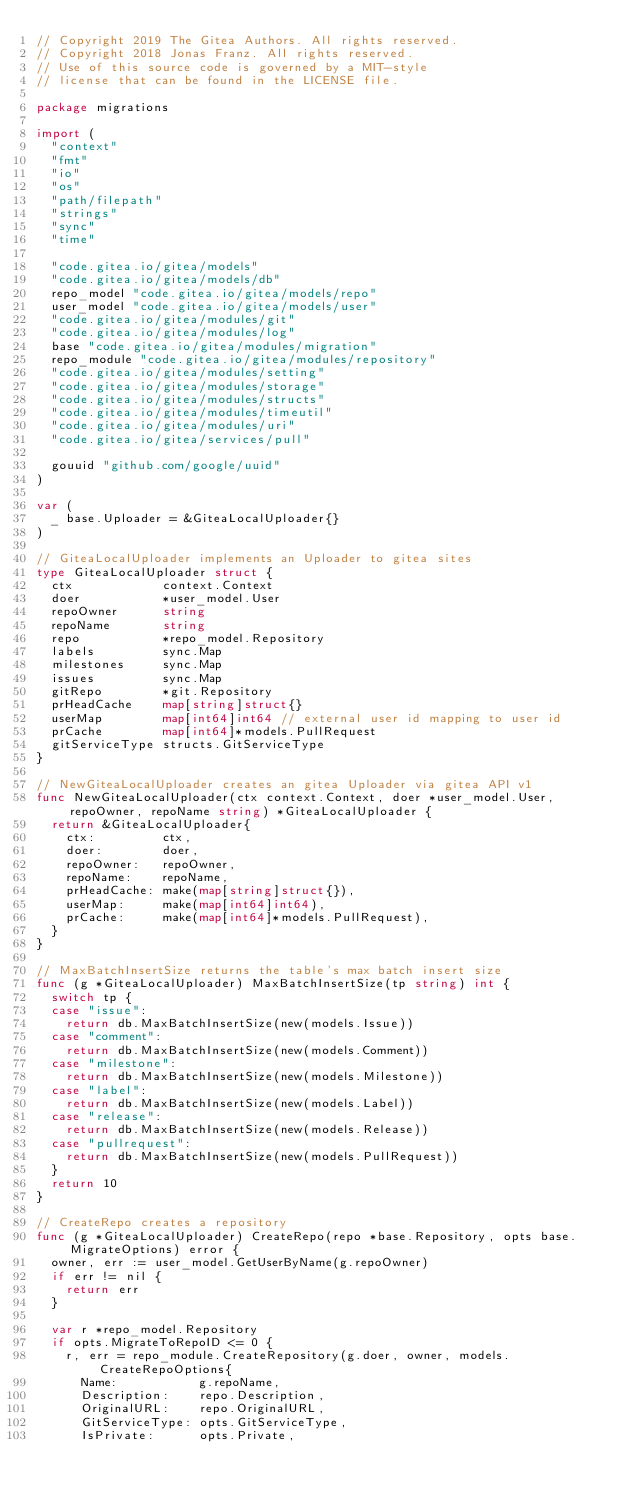<code> <loc_0><loc_0><loc_500><loc_500><_Go_>// Copyright 2019 The Gitea Authors. All rights reserved.
// Copyright 2018 Jonas Franz. All rights reserved.
// Use of this source code is governed by a MIT-style
// license that can be found in the LICENSE file.

package migrations

import (
	"context"
	"fmt"
	"io"
	"os"
	"path/filepath"
	"strings"
	"sync"
	"time"

	"code.gitea.io/gitea/models"
	"code.gitea.io/gitea/models/db"
	repo_model "code.gitea.io/gitea/models/repo"
	user_model "code.gitea.io/gitea/models/user"
	"code.gitea.io/gitea/modules/git"
	"code.gitea.io/gitea/modules/log"
	base "code.gitea.io/gitea/modules/migration"
	repo_module "code.gitea.io/gitea/modules/repository"
	"code.gitea.io/gitea/modules/setting"
	"code.gitea.io/gitea/modules/storage"
	"code.gitea.io/gitea/modules/structs"
	"code.gitea.io/gitea/modules/timeutil"
	"code.gitea.io/gitea/modules/uri"
	"code.gitea.io/gitea/services/pull"

	gouuid "github.com/google/uuid"
)

var (
	_ base.Uploader = &GiteaLocalUploader{}
)

// GiteaLocalUploader implements an Uploader to gitea sites
type GiteaLocalUploader struct {
	ctx            context.Context
	doer           *user_model.User
	repoOwner      string
	repoName       string
	repo           *repo_model.Repository
	labels         sync.Map
	milestones     sync.Map
	issues         sync.Map
	gitRepo        *git.Repository
	prHeadCache    map[string]struct{}
	userMap        map[int64]int64 // external user id mapping to user id
	prCache        map[int64]*models.PullRequest
	gitServiceType structs.GitServiceType
}

// NewGiteaLocalUploader creates an gitea Uploader via gitea API v1
func NewGiteaLocalUploader(ctx context.Context, doer *user_model.User, repoOwner, repoName string) *GiteaLocalUploader {
	return &GiteaLocalUploader{
		ctx:         ctx,
		doer:        doer,
		repoOwner:   repoOwner,
		repoName:    repoName,
		prHeadCache: make(map[string]struct{}),
		userMap:     make(map[int64]int64),
		prCache:     make(map[int64]*models.PullRequest),
	}
}

// MaxBatchInsertSize returns the table's max batch insert size
func (g *GiteaLocalUploader) MaxBatchInsertSize(tp string) int {
	switch tp {
	case "issue":
		return db.MaxBatchInsertSize(new(models.Issue))
	case "comment":
		return db.MaxBatchInsertSize(new(models.Comment))
	case "milestone":
		return db.MaxBatchInsertSize(new(models.Milestone))
	case "label":
		return db.MaxBatchInsertSize(new(models.Label))
	case "release":
		return db.MaxBatchInsertSize(new(models.Release))
	case "pullrequest":
		return db.MaxBatchInsertSize(new(models.PullRequest))
	}
	return 10
}

// CreateRepo creates a repository
func (g *GiteaLocalUploader) CreateRepo(repo *base.Repository, opts base.MigrateOptions) error {
	owner, err := user_model.GetUserByName(g.repoOwner)
	if err != nil {
		return err
	}

	var r *repo_model.Repository
	if opts.MigrateToRepoID <= 0 {
		r, err = repo_module.CreateRepository(g.doer, owner, models.CreateRepoOptions{
			Name:           g.repoName,
			Description:    repo.Description,
			OriginalURL:    repo.OriginalURL,
			GitServiceType: opts.GitServiceType,
			IsPrivate:      opts.Private,</code> 